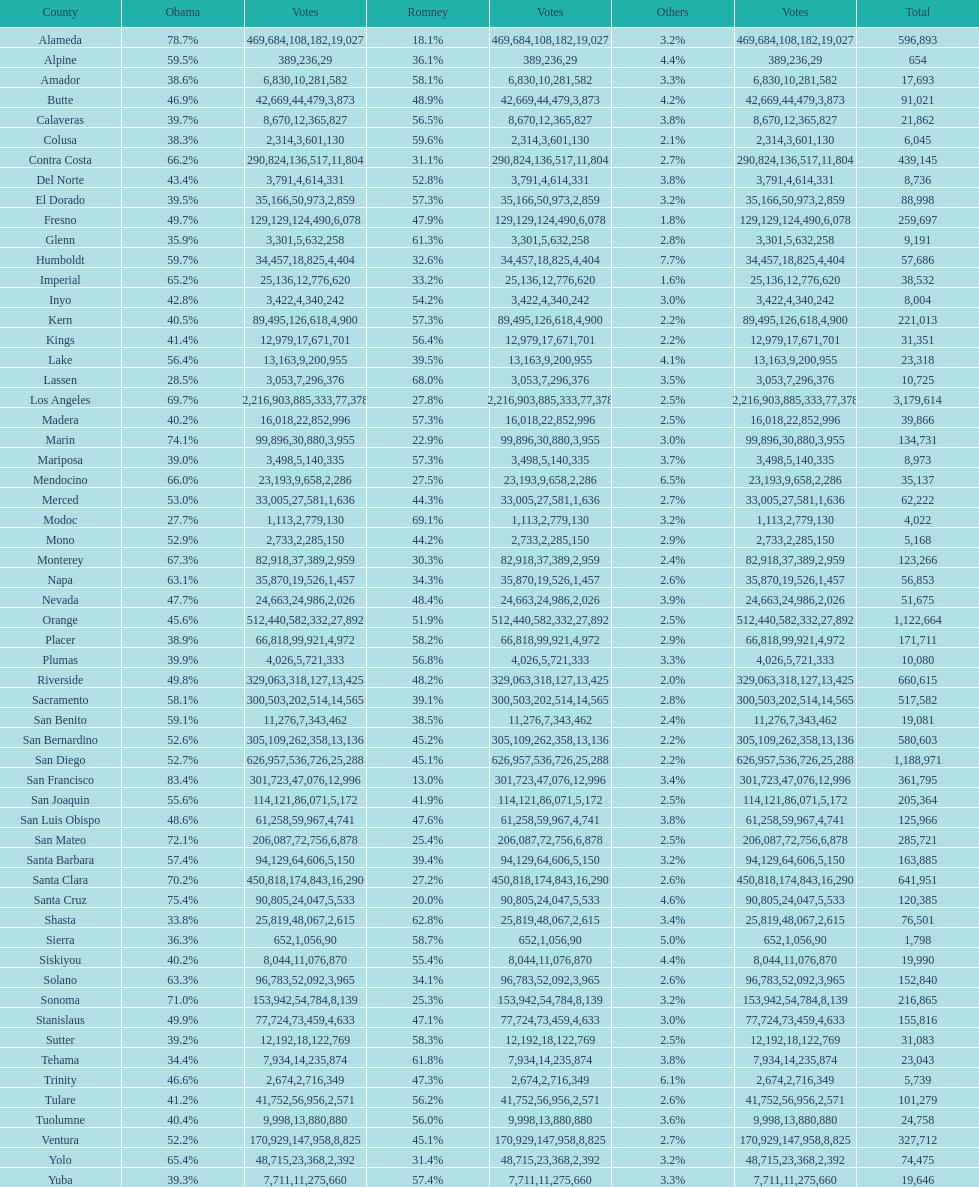What is the total number of votes for amador? 17693. 